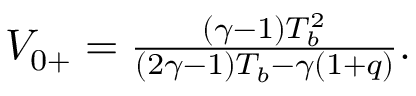<formula> <loc_0><loc_0><loc_500><loc_500>\begin{array} { r } { V _ { 0 + } = \frac { ( \gamma - 1 ) T _ { b } ^ { 2 } } { ( 2 \gamma - 1 ) T _ { b } - \gamma ( 1 + q ) } . } \end{array}</formula> 